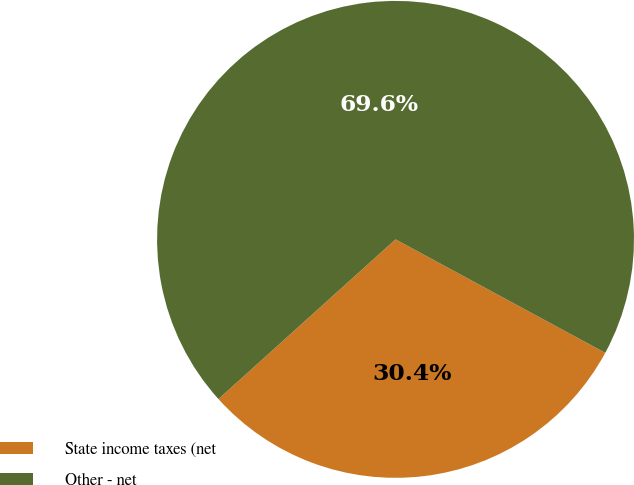<chart> <loc_0><loc_0><loc_500><loc_500><pie_chart><fcel>State income taxes (net<fcel>Other - net<nl><fcel>30.43%<fcel>69.57%<nl></chart> 